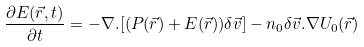<formula> <loc_0><loc_0><loc_500><loc_500>\frac { \partial E ( \vec { r } , t ) } { \partial t } = - \nabla . [ ( P ( \vec { r } ) + E ( \vec { r } ) ) \delta \vec { v } ] - n _ { 0 } \delta \vec { v } . \nabla U _ { 0 } ( \vec { r } )</formula> 